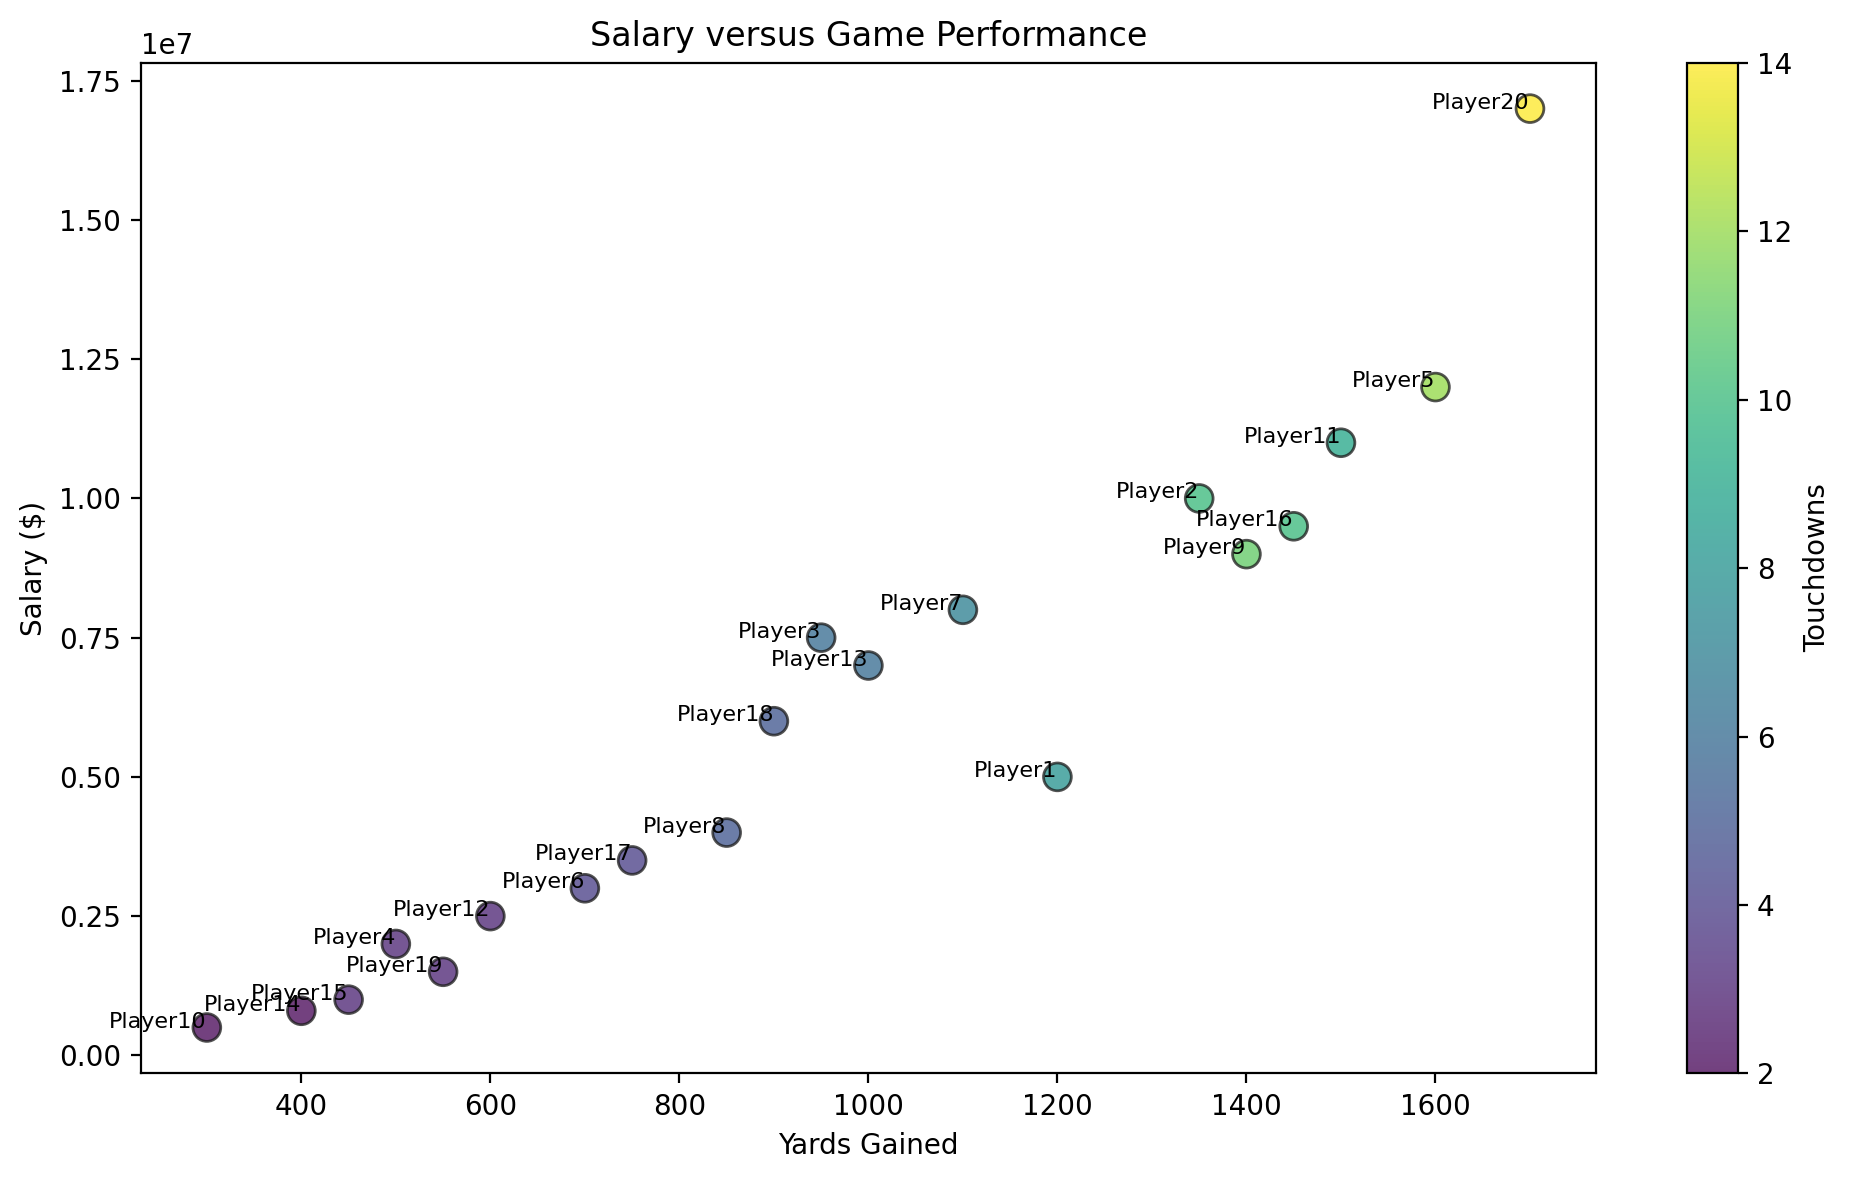What is the highest salary in the scatter plot, and which player does it belong to? The player "Player20" has the highest salary. The salary value is $17,000,000. This can be determined by identifying the highest point on the vertical axis (salary) and noting the annotated player name next to it.
Answer: 17,000,000; Player20 Which player gained the most yards, and how many yards were gained? The player "Player20" gained the most yards. This can be identified by locating the farthest point to the right on the horizontal axis (yards gained) and noting the annotated player name next to it. The number of yards gained is 1700.
Answer: Player20; 1700 Which player has the lowest salary, and how many yards did they gain? The player "Player10" has the lowest salary. This can be determined by identifying the lowest point on the vertical axis (salary) and noting the player name next to it. "Player10" gained 300 yards.
Answer: Player10; 300 How does the salary of "Player5" compare to "Player3"? "Player5" has a higher salary compared to "Player3". To answer, look at the vertical positions of both players’ annotations. "Player5" (at $12,000,000) is above "Player3" (at $7,500,000).
Answer: Player5 has a higher salary What is the average number of touchdowns for players earning $10,000,000 or more? First, identify players earning $10,000,000 or more ("Player2", "Player5", "Player9", "Player11", "Player16", "Player20"). Then, sum their touchdowns: 10 (Player2) + 12 (Player5) + 11 (Player9) + 9 (Player11) + 10 (Player16) + 14 (Player20) = 66. There are 6 players, so average = 66 / 6.
Answer: 11 Which players have the same number of touchdowns but different salaries? Compare the number of touchdowns for each player: 
- "Player3" and "Player13" both have 6 touchdowns; their salaries differ ($7,500,000 vs. $7,000,000).
- "Player4" and "Player12" both have 3 touchdowns; their salaries differ ($2,000,000 vs. $2,500,000).
Answer: Player3 and Player13; Player4 and Player12 Does a higher number of touchdowns always correspond to a higher salary? It does not seem to be directly correlated. For example, "Player11" has 9 touchdowns and makes $11,000,000, whereas "Player2" has 10 touchdowns but makes $10,000,000.
Answer: No How many players are earning below $2,500,000 and how many yards did the top performer among them gain? Identify players earning below $2,500,000 ("Player4", "Player10", "Player14", "Player15", "Player19"). There are 5 players in this category. "Player4" gained the most yards among them with 500 yards.
Answer: 5 players; 500 yards Is there any outlier player in terms of salary and touchdowns? "Player20" has both the highest salary ($17,000,000) and the highest number of touchdowns (14), making them an outlier in the dataset. Identify outliers by locating extremities on both axes.
Answer: Player20 Which player who gained between 800 and 900 yards has the highest salary? Among players who gained between 800 and 900 yards are "Player8" and "Player18". "Player18" has a higher salary of $6,000,000 compared to "Player8" with $4,000,000.
Answer: Player18 